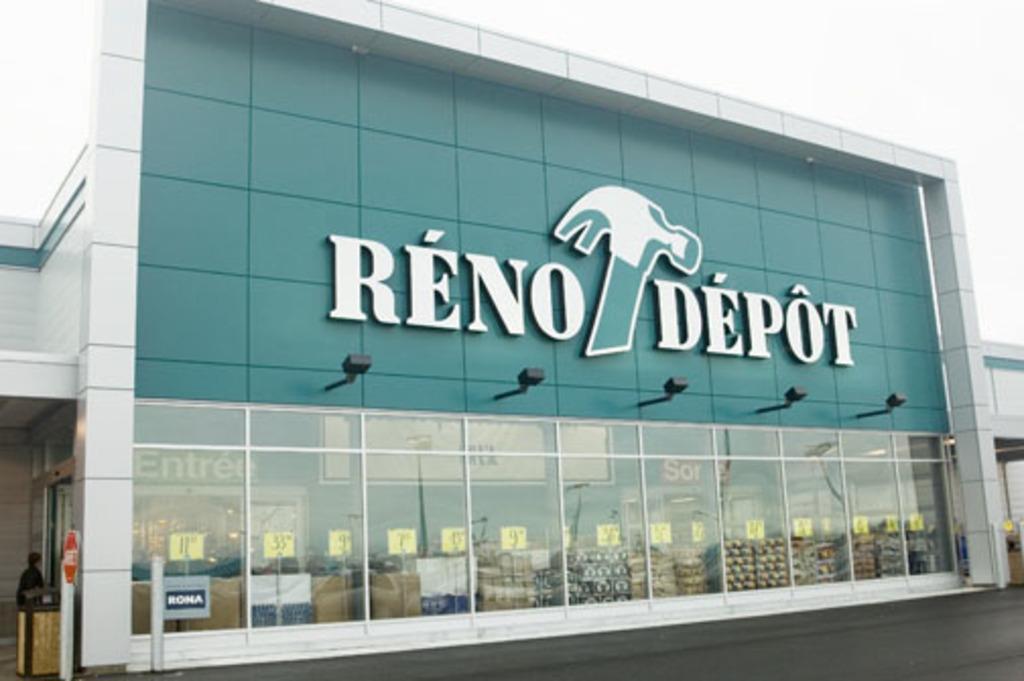Can you describe this image briefly? In this image, we can see a building which is colored white and green. There are lights on the building. There is a sky in the top right of the image. 